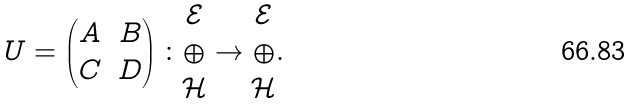Convert formula to latex. <formula><loc_0><loc_0><loc_500><loc_500>U = \begin{pmatrix} A & B \\ C & D \end{pmatrix} \colon \begin{matrix} \mathcal { E } \\ \oplus \\ \mathcal { H } \end{matrix} \to \begin{matrix} \mathcal { E } \\ \oplus \\ \mathcal { H } \end{matrix} .</formula> 